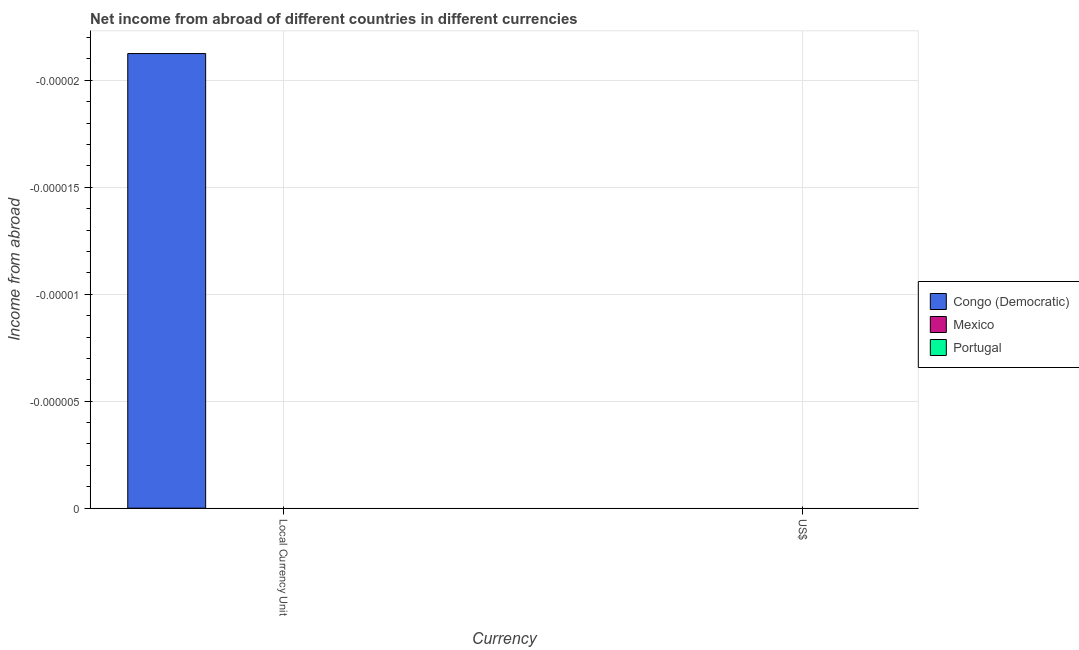How many different coloured bars are there?
Give a very brief answer. 0. Are the number of bars per tick equal to the number of legend labels?
Provide a succinct answer. No. What is the label of the 2nd group of bars from the left?
Give a very brief answer. US$. Across all countries, what is the minimum income from abroad in constant 2005 us$?
Keep it short and to the point. 0. What is the average income from abroad in constant 2005 us$ per country?
Ensure brevity in your answer.  0. In how many countries, is the income from abroad in constant 2005 us$ greater than the average income from abroad in constant 2005 us$ taken over all countries?
Offer a terse response. 0. How many bars are there?
Make the answer very short. 0. Are all the bars in the graph horizontal?
Offer a terse response. No. What is the difference between two consecutive major ticks on the Y-axis?
Offer a terse response. 5.000000000000001e-6. Does the graph contain any zero values?
Your answer should be compact. Yes. Does the graph contain grids?
Your answer should be very brief. Yes. How many legend labels are there?
Provide a short and direct response. 3. How are the legend labels stacked?
Give a very brief answer. Vertical. What is the title of the graph?
Offer a terse response. Net income from abroad of different countries in different currencies. What is the label or title of the X-axis?
Your answer should be compact. Currency. What is the label or title of the Y-axis?
Give a very brief answer. Income from abroad. What is the Income from abroad of Portugal in Local Currency Unit?
Your answer should be compact. 0. What is the Income from abroad of Portugal in US$?
Your answer should be very brief. 0. What is the total Income from abroad in Mexico in the graph?
Make the answer very short. 0. What is the average Income from abroad of Congo (Democratic) per Currency?
Your response must be concise. 0. What is the average Income from abroad in Mexico per Currency?
Your answer should be compact. 0. 